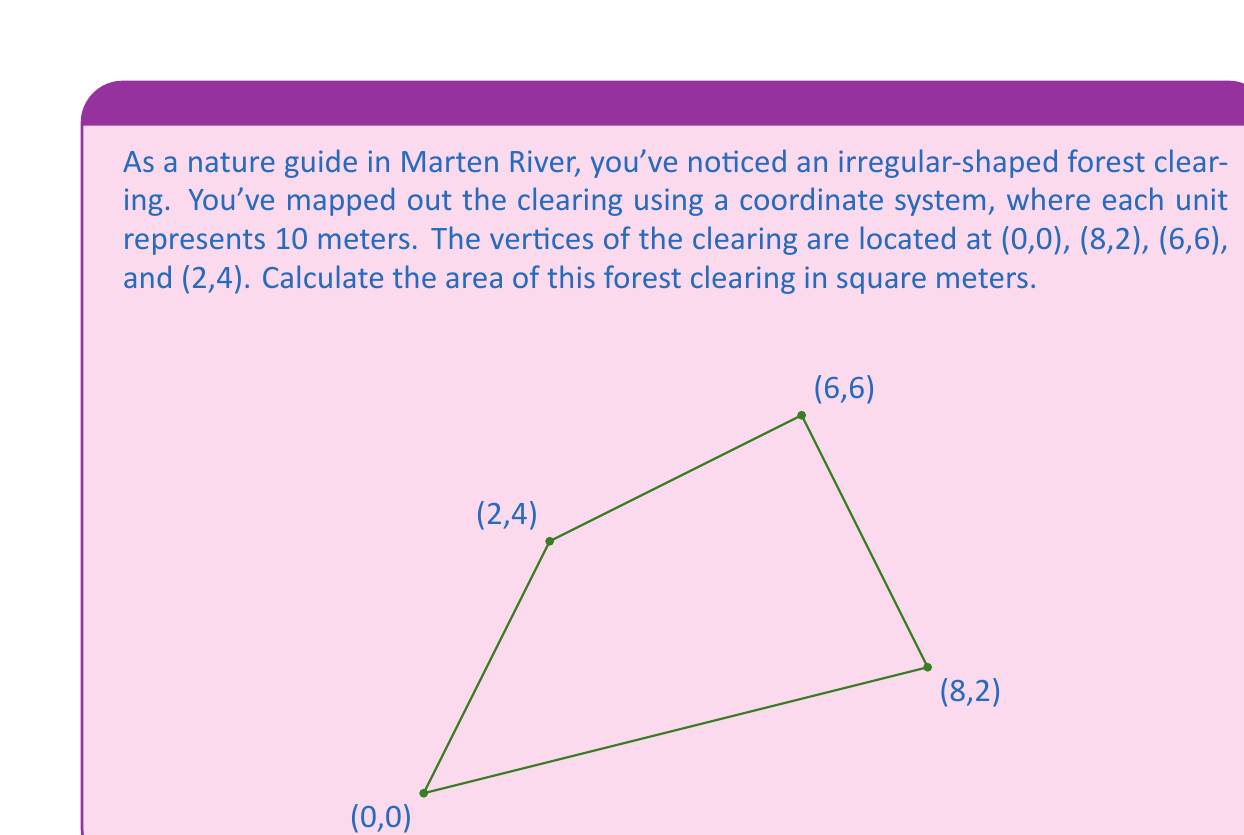What is the answer to this math problem? To calculate the area of this irregular-shaped forest clearing, we can use the Shoelace formula (also known as the surveyor's formula). This formula calculates the area of a polygon given the coordinates of its vertices.

The Shoelace formula is:

$$ A = \frac{1}{2}|\sum_{i=1}^{n-1} (x_iy_{i+1} + x_ny_1) - \sum_{i=1}^{n-1} (y_ix_{i+1} + y_nx_1)| $$

Where $(x_i, y_i)$ are the coordinates of the $i$-th vertex.

Let's apply this formula to our forest clearing:

1) First, let's list our coordinates in order:
   $(x_1, y_1) = (0, 0)$
   $(x_2, y_2) = (8, 2)$
   $(x_3, y_3) = (6, 6)$
   $(x_4, y_4) = (2, 4)$

2) Now, let's calculate the first sum:
   $x_1y_2 + x_2y_3 + x_3y_4 + x_4y_1 = (0 \cdot 2) + (8 \cdot 6) + (6 \cdot 4) + (2 \cdot 0) = 0 + 48 + 24 + 0 = 72$

3) Calculate the second sum:
   $y_1x_2 + y_2x_3 + y_3x_4 + y_4x_1 = (0 \cdot 8) + (2 \cdot 6) + (6 \cdot 2) + (4 \cdot 0) = 0 + 12 + 12 + 0 = 24$

4) Subtract the second sum from the first:
   $72 - 24 = 48$

5) Divide by 2:
   $\frac{48}{2} = 24$

6) The result, 24, represents the area in square units. Since each unit represents 10 meters, we need to multiply by 100 to get the area in square meters:
   $24 \cdot 100 = 2400$ square meters

Therefore, the area of the forest clearing is 2400 square meters.
Answer: 2400 square meters 